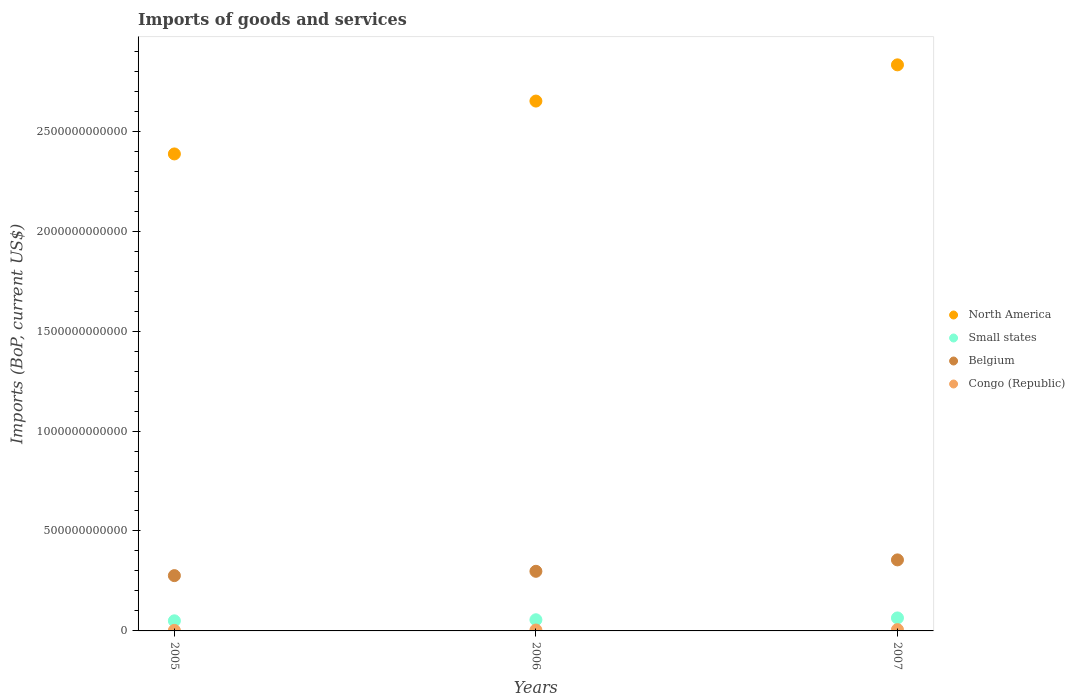How many different coloured dotlines are there?
Offer a terse response. 4. What is the amount spent on imports in Congo (Republic) in 2007?
Offer a terse response. 6.39e+09. Across all years, what is the maximum amount spent on imports in Belgium?
Offer a terse response. 3.55e+11. Across all years, what is the minimum amount spent on imports in Belgium?
Ensure brevity in your answer.  2.77e+11. In which year was the amount spent on imports in Congo (Republic) maximum?
Your answer should be compact. 2007. What is the total amount spent on imports in Belgium in the graph?
Offer a terse response. 9.30e+11. What is the difference between the amount spent on imports in North America in 2005 and that in 2006?
Keep it short and to the point. -2.65e+11. What is the difference between the amount spent on imports in Small states in 2006 and the amount spent on imports in Belgium in 2005?
Your answer should be very brief. -2.21e+11. What is the average amount spent on imports in Small states per year?
Provide a short and direct response. 5.71e+1. In the year 2007, what is the difference between the amount spent on imports in Belgium and amount spent on imports in North America?
Your answer should be very brief. -2.48e+12. In how many years, is the amount spent on imports in Belgium greater than 2200000000000 US$?
Provide a succinct answer. 0. What is the ratio of the amount spent on imports in North America in 2006 to that in 2007?
Keep it short and to the point. 0.94. Is the amount spent on imports in Small states in 2005 less than that in 2007?
Keep it short and to the point. Yes. Is the difference between the amount spent on imports in Belgium in 2005 and 2006 greater than the difference between the amount spent on imports in North America in 2005 and 2006?
Give a very brief answer. Yes. What is the difference between the highest and the second highest amount spent on imports in Congo (Republic)?
Make the answer very short. 1.96e+09. What is the difference between the highest and the lowest amount spent on imports in Congo (Republic)?
Give a very brief answer. 3.66e+09. In how many years, is the amount spent on imports in Small states greater than the average amount spent on imports in Small states taken over all years?
Your response must be concise. 1. Is the sum of the amount spent on imports in North America in 2005 and 2006 greater than the maximum amount spent on imports in Small states across all years?
Your response must be concise. Yes. Is it the case that in every year, the sum of the amount spent on imports in Congo (Republic) and amount spent on imports in Belgium  is greater than the amount spent on imports in North America?
Your response must be concise. No. Does the amount spent on imports in Small states monotonically increase over the years?
Your answer should be compact. Yes. Is the amount spent on imports in Belgium strictly greater than the amount spent on imports in Congo (Republic) over the years?
Your answer should be very brief. Yes. Is the amount spent on imports in Belgium strictly less than the amount spent on imports in Congo (Republic) over the years?
Your response must be concise. No. What is the difference between two consecutive major ticks on the Y-axis?
Your answer should be compact. 5.00e+11. Where does the legend appear in the graph?
Your response must be concise. Center right. How many legend labels are there?
Your response must be concise. 4. What is the title of the graph?
Ensure brevity in your answer.  Imports of goods and services. Does "Sierra Leone" appear as one of the legend labels in the graph?
Your answer should be compact. No. What is the label or title of the X-axis?
Your answer should be very brief. Years. What is the label or title of the Y-axis?
Ensure brevity in your answer.  Imports (BoP, current US$). What is the Imports (BoP, current US$) in North America in 2005?
Keep it short and to the point. 2.39e+12. What is the Imports (BoP, current US$) in Small states in 2005?
Your response must be concise. 5.06e+1. What is the Imports (BoP, current US$) of Belgium in 2005?
Give a very brief answer. 2.77e+11. What is the Imports (BoP, current US$) in Congo (Republic) in 2005?
Keep it short and to the point. 2.72e+09. What is the Imports (BoP, current US$) of North America in 2006?
Your answer should be very brief. 2.65e+12. What is the Imports (BoP, current US$) in Small states in 2006?
Offer a terse response. 5.58e+1. What is the Imports (BoP, current US$) of Belgium in 2006?
Your answer should be very brief. 2.98e+11. What is the Imports (BoP, current US$) in Congo (Republic) in 2006?
Ensure brevity in your answer.  4.43e+09. What is the Imports (BoP, current US$) of North America in 2007?
Give a very brief answer. 2.83e+12. What is the Imports (BoP, current US$) in Small states in 2007?
Keep it short and to the point. 6.50e+1. What is the Imports (BoP, current US$) of Belgium in 2007?
Make the answer very short. 3.55e+11. What is the Imports (BoP, current US$) in Congo (Republic) in 2007?
Offer a terse response. 6.39e+09. Across all years, what is the maximum Imports (BoP, current US$) in North America?
Offer a very short reply. 2.83e+12. Across all years, what is the maximum Imports (BoP, current US$) in Small states?
Ensure brevity in your answer.  6.50e+1. Across all years, what is the maximum Imports (BoP, current US$) of Belgium?
Provide a succinct answer. 3.55e+11. Across all years, what is the maximum Imports (BoP, current US$) in Congo (Republic)?
Your response must be concise. 6.39e+09. Across all years, what is the minimum Imports (BoP, current US$) in North America?
Make the answer very short. 2.39e+12. Across all years, what is the minimum Imports (BoP, current US$) of Small states?
Offer a very short reply. 5.06e+1. Across all years, what is the minimum Imports (BoP, current US$) of Belgium?
Make the answer very short. 2.77e+11. Across all years, what is the minimum Imports (BoP, current US$) of Congo (Republic)?
Provide a succinct answer. 2.72e+09. What is the total Imports (BoP, current US$) of North America in the graph?
Offer a very short reply. 7.87e+12. What is the total Imports (BoP, current US$) in Small states in the graph?
Offer a terse response. 1.71e+11. What is the total Imports (BoP, current US$) of Belgium in the graph?
Your answer should be very brief. 9.30e+11. What is the total Imports (BoP, current US$) in Congo (Republic) in the graph?
Offer a terse response. 1.35e+1. What is the difference between the Imports (BoP, current US$) of North America in 2005 and that in 2006?
Your answer should be compact. -2.65e+11. What is the difference between the Imports (BoP, current US$) in Small states in 2005 and that in 2006?
Offer a terse response. -5.28e+09. What is the difference between the Imports (BoP, current US$) of Belgium in 2005 and that in 2006?
Offer a terse response. -2.16e+1. What is the difference between the Imports (BoP, current US$) of Congo (Republic) in 2005 and that in 2006?
Make the answer very short. -1.71e+09. What is the difference between the Imports (BoP, current US$) of North America in 2005 and that in 2007?
Ensure brevity in your answer.  -4.46e+11. What is the difference between the Imports (BoP, current US$) in Small states in 2005 and that in 2007?
Ensure brevity in your answer.  -1.44e+1. What is the difference between the Imports (BoP, current US$) in Belgium in 2005 and that in 2007?
Your answer should be compact. -7.87e+1. What is the difference between the Imports (BoP, current US$) in Congo (Republic) in 2005 and that in 2007?
Your answer should be compact. -3.66e+09. What is the difference between the Imports (BoP, current US$) in North America in 2006 and that in 2007?
Make the answer very short. -1.81e+11. What is the difference between the Imports (BoP, current US$) in Small states in 2006 and that in 2007?
Ensure brevity in your answer.  -9.12e+09. What is the difference between the Imports (BoP, current US$) of Belgium in 2006 and that in 2007?
Offer a very short reply. -5.71e+1. What is the difference between the Imports (BoP, current US$) in Congo (Republic) in 2006 and that in 2007?
Offer a very short reply. -1.96e+09. What is the difference between the Imports (BoP, current US$) of North America in 2005 and the Imports (BoP, current US$) of Small states in 2006?
Make the answer very short. 2.33e+12. What is the difference between the Imports (BoP, current US$) in North America in 2005 and the Imports (BoP, current US$) in Belgium in 2006?
Provide a short and direct response. 2.09e+12. What is the difference between the Imports (BoP, current US$) of North America in 2005 and the Imports (BoP, current US$) of Congo (Republic) in 2006?
Ensure brevity in your answer.  2.38e+12. What is the difference between the Imports (BoP, current US$) of Small states in 2005 and the Imports (BoP, current US$) of Belgium in 2006?
Your answer should be compact. -2.48e+11. What is the difference between the Imports (BoP, current US$) of Small states in 2005 and the Imports (BoP, current US$) of Congo (Republic) in 2006?
Keep it short and to the point. 4.61e+1. What is the difference between the Imports (BoP, current US$) in Belgium in 2005 and the Imports (BoP, current US$) in Congo (Republic) in 2006?
Ensure brevity in your answer.  2.72e+11. What is the difference between the Imports (BoP, current US$) in North America in 2005 and the Imports (BoP, current US$) in Small states in 2007?
Your answer should be compact. 2.32e+12. What is the difference between the Imports (BoP, current US$) in North America in 2005 and the Imports (BoP, current US$) in Belgium in 2007?
Make the answer very short. 2.03e+12. What is the difference between the Imports (BoP, current US$) of North America in 2005 and the Imports (BoP, current US$) of Congo (Republic) in 2007?
Your answer should be very brief. 2.38e+12. What is the difference between the Imports (BoP, current US$) of Small states in 2005 and the Imports (BoP, current US$) of Belgium in 2007?
Make the answer very short. -3.05e+11. What is the difference between the Imports (BoP, current US$) in Small states in 2005 and the Imports (BoP, current US$) in Congo (Republic) in 2007?
Keep it short and to the point. 4.42e+1. What is the difference between the Imports (BoP, current US$) in Belgium in 2005 and the Imports (BoP, current US$) in Congo (Republic) in 2007?
Give a very brief answer. 2.70e+11. What is the difference between the Imports (BoP, current US$) of North America in 2006 and the Imports (BoP, current US$) of Small states in 2007?
Provide a short and direct response. 2.59e+12. What is the difference between the Imports (BoP, current US$) in North America in 2006 and the Imports (BoP, current US$) in Belgium in 2007?
Provide a short and direct response. 2.30e+12. What is the difference between the Imports (BoP, current US$) of North America in 2006 and the Imports (BoP, current US$) of Congo (Republic) in 2007?
Make the answer very short. 2.64e+12. What is the difference between the Imports (BoP, current US$) of Small states in 2006 and the Imports (BoP, current US$) of Belgium in 2007?
Your answer should be compact. -3.00e+11. What is the difference between the Imports (BoP, current US$) of Small states in 2006 and the Imports (BoP, current US$) of Congo (Republic) in 2007?
Provide a succinct answer. 4.95e+1. What is the difference between the Imports (BoP, current US$) in Belgium in 2006 and the Imports (BoP, current US$) in Congo (Republic) in 2007?
Provide a succinct answer. 2.92e+11. What is the average Imports (BoP, current US$) of North America per year?
Your answer should be very brief. 2.62e+12. What is the average Imports (BoP, current US$) of Small states per year?
Offer a very short reply. 5.71e+1. What is the average Imports (BoP, current US$) of Belgium per year?
Provide a short and direct response. 3.10e+11. What is the average Imports (BoP, current US$) of Congo (Republic) per year?
Keep it short and to the point. 4.51e+09. In the year 2005, what is the difference between the Imports (BoP, current US$) in North America and Imports (BoP, current US$) in Small states?
Your response must be concise. 2.34e+12. In the year 2005, what is the difference between the Imports (BoP, current US$) in North America and Imports (BoP, current US$) in Belgium?
Your answer should be very brief. 2.11e+12. In the year 2005, what is the difference between the Imports (BoP, current US$) of North America and Imports (BoP, current US$) of Congo (Republic)?
Give a very brief answer. 2.38e+12. In the year 2005, what is the difference between the Imports (BoP, current US$) of Small states and Imports (BoP, current US$) of Belgium?
Make the answer very short. -2.26e+11. In the year 2005, what is the difference between the Imports (BoP, current US$) of Small states and Imports (BoP, current US$) of Congo (Republic)?
Offer a terse response. 4.78e+1. In the year 2005, what is the difference between the Imports (BoP, current US$) in Belgium and Imports (BoP, current US$) in Congo (Republic)?
Make the answer very short. 2.74e+11. In the year 2006, what is the difference between the Imports (BoP, current US$) of North America and Imports (BoP, current US$) of Small states?
Your answer should be compact. 2.60e+12. In the year 2006, what is the difference between the Imports (BoP, current US$) in North America and Imports (BoP, current US$) in Belgium?
Your answer should be compact. 2.35e+12. In the year 2006, what is the difference between the Imports (BoP, current US$) of North America and Imports (BoP, current US$) of Congo (Republic)?
Offer a very short reply. 2.65e+12. In the year 2006, what is the difference between the Imports (BoP, current US$) of Small states and Imports (BoP, current US$) of Belgium?
Your answer should be compact. -2.42e+11. In the year 2006, what is the difference between the Imports (BoP, current US$) in Small states and Imports (BoP, current US$) in Congo (Republic)?
Offer a very short reply. 5.14e+1. In the year 2006, what is the difference between the Imports (BoP, current US$) of Belgium and Imports (BoP, current US$) of Congo (Republic)?
Keep it short and to the point. 2.94e+11. In the year 2007, what is the difference between the Imports (BoP, current US$) in North America and Imports (BoP, current US$) in Small states?
Your answer should be compact. 2.77e+12. In the year 2007, what is the difference between the Imports (BoP, current US$) in North America and Imports (BoP, current US$) in Belgium?
Give a very brief answer. 2.48e+12. In the year 2007, what is the difference between the Imports (BoP, current US$) in North America and Imports (BoP, current US$) in Congo (Republic)?
Provide a short and direct response. 2.83e+12. In the year 2007, what is the difference between the Imports (BoP, current US$) in Small states and Imports (BoP, current US$) in Belgium?
Make the answer very short. -2.90e+11. In the year 2007, what is the difference between the Imports (BoP, current US$) of Small states and Imports (BoP, current US$) of Congo (Republic)?
Offer a very short reply. 5.86e+1. In the year 2007, what is the difference between the Imports (BoP, current US$) of Belgium and Imports (BoP, current US$) of Congo (Republic)?
Keep it short and to the point. 3.49e+11. What is the ratio of the Imports (BoP, current US$) in North America in 2005 to that in 2006?
Provide a short and direct response. 0.9. What is the ratio of the Imports (BoP, current US$) of Small states in 2005 to that in 2006?
Your answer should be very brief. 0.91. What is the ratio of the Imports (BoP, current US$) of Belgium in 2005 to that in 2006?
Make the answer very short. 0.93. What is the ratio of the Imports (BoP, current US$) of Congo (Republic) in 2005 to that in 2006?
Your answer should be very brief. 0.61. What is the ratio of the Imports (BoP, current US$) in North America in 2005 to that in 2007?
Give a very brief answer. 0.84. What is the ratio of the Imports (BoP, current US$) in Small states in 2005 to that in 2007?
Ensure brevity in your answer.  0.78. What is the ratio of the Imports (BoP, current US$) of Belgium in 2005 to that in 2007?
Ensure brevity in your answer.  0.78. What is the ratio of the Imports (BoP, current US$) in Congo (Republic) in 2005 to that in 2007?
Offer a terse response. 0.43. What is the ratio of the Imports (BoP, current US$) of North America in 2006 to that in 2007?
Your answer should be very brief. 0.94. What is the ratio of the Imports (BoP, current US$) of Small states in 2006 to that in 2007?
Your response must be concise. 0.86. What is the ratio of the Imports (BoP, current US$) of Belgium in 2006 to that in 2007?
Your answer should be very brief. 0.84. What is the ratio of the Imports (BoP, current US$) of Congo (Republic) in 2006 to that in 2007?
Give a very brief answer. 0.69. What is the difference between the highest and the second highest Imports (BoP, current US$) of North America?
Give a very brief answer. 1.81e+11. What is the difference between the highest and the second highest Imports (BoP, current US$) of Small states?
Offer a very short reply. 9.12e+09. What is the difference between the highest and the second highest Imports (BoP, current US$) of Belgium?
Provide a short and direct response. 5.71e+1. What is the difference between the highest and the second highest Imports (BoP, current US$) in Congo (Republic)?
Your response must be concise. 1.96e+09. What is the difference between the highest and the lowest Imports (BoP, current US$) in North America?
Provide a short and direct response. 4.46e+11. What is the difference between the highest and the lowest Imports (BoP, current US$) of Small states?
Give a very brief answer. 1.44e+1. What is the difference between the highest and the lowest Imports (BoP, current US$) of Belgium?
Your response must be concise. 7.87e+1. What is the difference between the highest and the lowest Imports (BoP, current US$) of Congo (Republic)?
Give a very brief answer. 3.66e+09. 